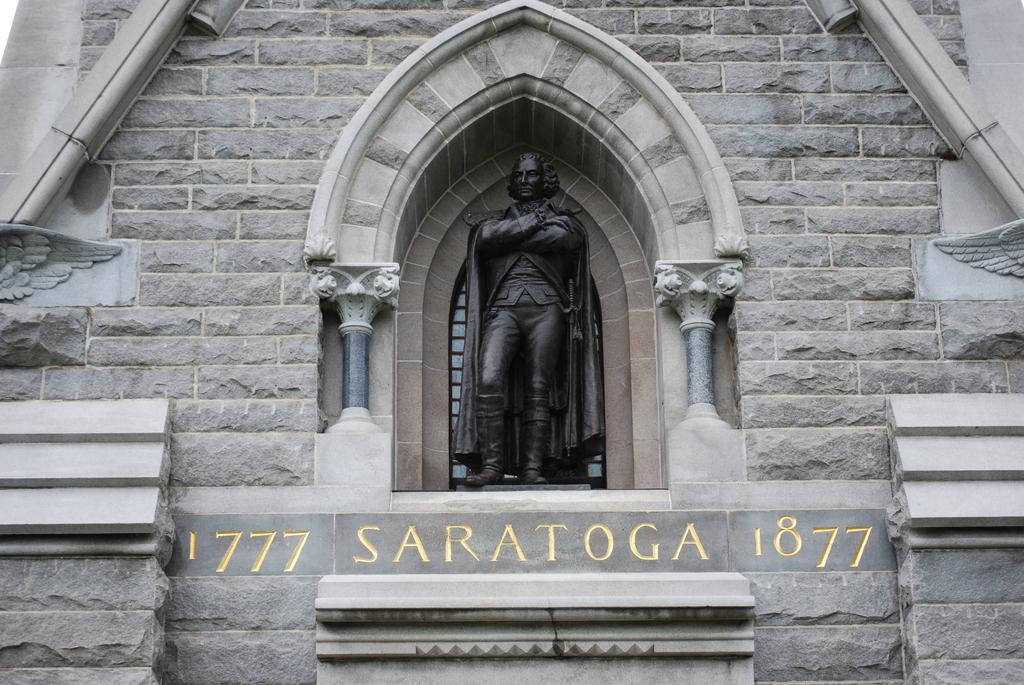What is the main subject of the image? The main subject of the image is a wall of a building. What can be seen on the building? There is text on the building. What is located in the center of the wall? There is a sculpture of a man in the center of the wall. What type of hair can be seen on the kitten in the image? There is no kitten present in the image, so there is no hair to observe. 